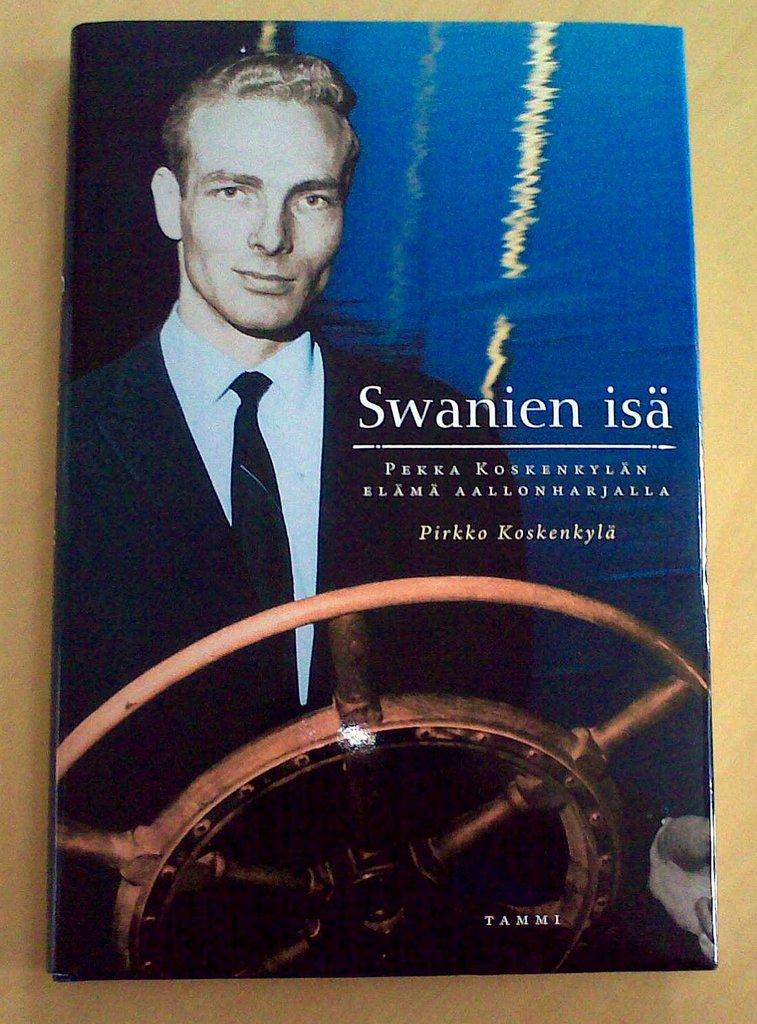<image>
Describe the image concisely. the cover of a book called 'swanien isa' by pirkko koskenkyla 